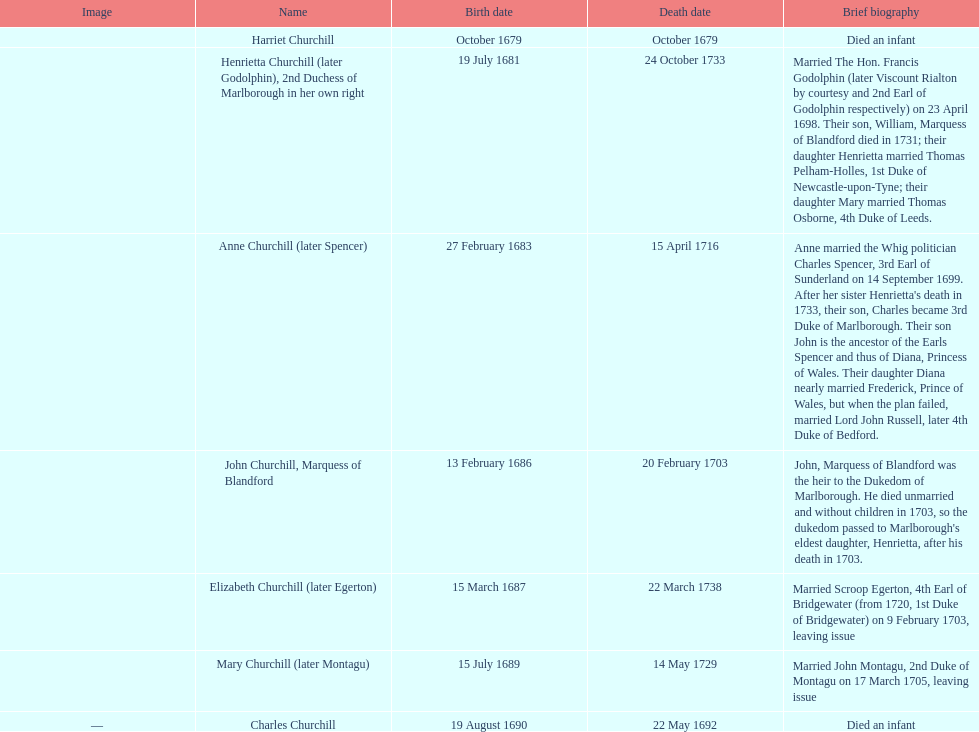What is the overall count of children mentioned? 7. 